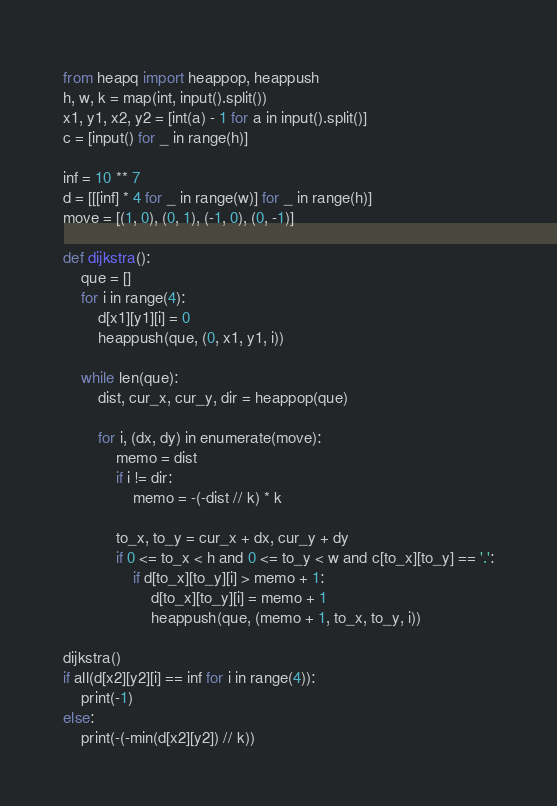<code> <loc_0><loc_0><loc_500><loc_500><_Python_>from heapq import heappop, heappush
h, w, k = map(int, input().split())
x1, y1, x2, y2 = [int(a) - 1 for a in input().split()]
c = [input() for _ in range(h)]

inf = 10 ** 7
d = [[[inf] * 4 for _ in range(w)] for _ in range(h)]
move = [(1, 0), (0, 1), (-1, 0), (0, -1)]

def dijkstra():
    que = []
    for i in range(4):
        d[x1][y1][i] = 0
        heappush(que, (0, x1, y1, i))
    
    while len(que):
        dist, cur_x, cur_y, dir = heappop(que)
    
        for i, (dx, dy) in enumerate(move):
            memo = dist
            if i != dir:
                memo = -(-dist // k) * k
            
            to_x, to_y = cur_x + dx, cur_y + dy
            if 0 <= to_x < h and 0 <= to_y < w and c[to_x][to_y] == '.':
                if d[to_x][to_y][i] > memo + 1:
                    d[to_x][to_y][i] = memo + 1
                    heappush(que, (memo + 1, to_x, to_y, i))

dijkstra()
if all(d[x2][y2][i] == inf for i in range(4)):
    print(-1)
else:
    print(-(-min(d[x2][y2]) // k))</code> 